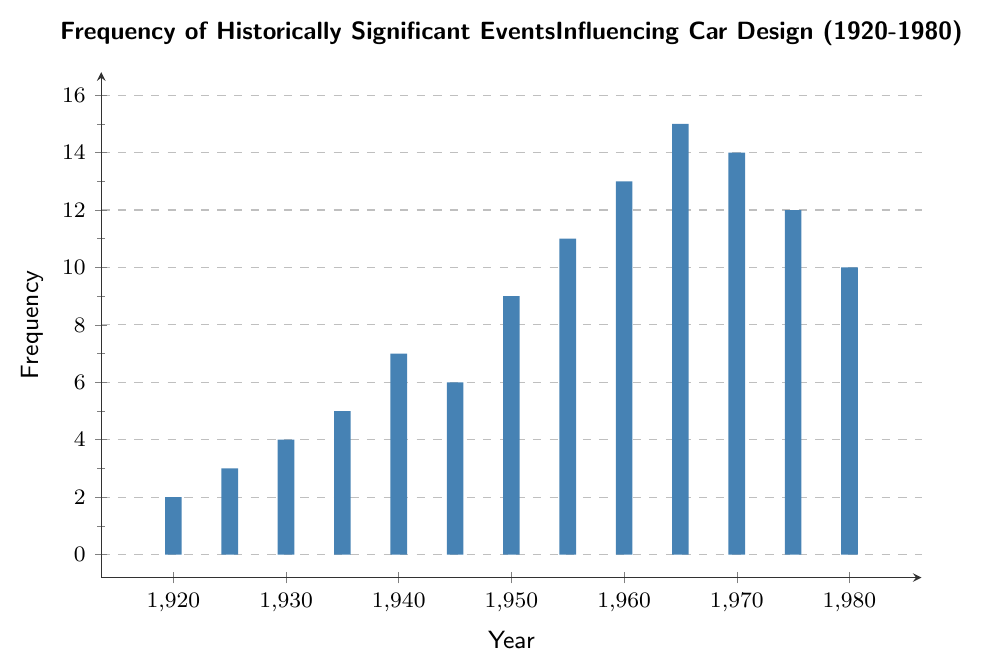What year had the highest frequency of historically significant events influencing car design? The year with the highest bar in the chart represents the highest frequency. The highest bar occurs in 1965 at 15.
Answer: 1965 How does the frequency of events in 1940 compare to 1980? The bar for 1940 reaches 7, while for 1980, it reaches 10. Since 10 is greater than 7, the frequency in 1980 is higher than in 1940.
Answer: 1980, higher What is the total frequency of events from 1960 to 1970? Add the frequencies for the years 1960, 1965, and 1970: 13 + 15 + 14 = 42.
Answer: 42 What is the difference in the frequency of events between 1955 and 1975? Subtract the frequency in 1955 from that in 1975: 12 - 11 =1.
Answer: 1 What is the average frequency of events in the 1920s? There are two data points for the 1920s: 1920 (2) and 1925 (3). The average is (2 + 3) / 2 = 2.5.
Answer: 2.5 Which decade had the most consistent frequency of events, and how do you determine consistency? Consistency can be determined by the minimal changes in frequency. By observing the bar heights, the 1930s show the most consistent frequency: 1930 (4) and 1935 (5).
Answer: 1930s Comparing the frequencies, was the 1960s generally higher than the 1940s? The 1960s frequencies are 13 and 15, while the 1940s are 7 and 6. Since both values in the 1960s are higher than those in the 1940s, the 1960s were generally higher.
Answer: Yes, higher Calculate the range of frequencies between 1920 and 1980. The range is the difference between the highest and lowest frequencies. The highest frequency is 15 (1965) and the lowest is 2 (1920), so the range is 15 - 2 = 13.
Answer: 13 What was the increase in frequency of events from 1950 to 1960? The frequency in 1950 is 9, and in 1960 is 13. The increase is 13 - 9 = 4.
Answer: 4 By how much did the frequency change from 1940 to 1945? The frequency in 1940 is 7 and in 1945 is 6. The change is 7 - 6 = 1.
Answer: 1 